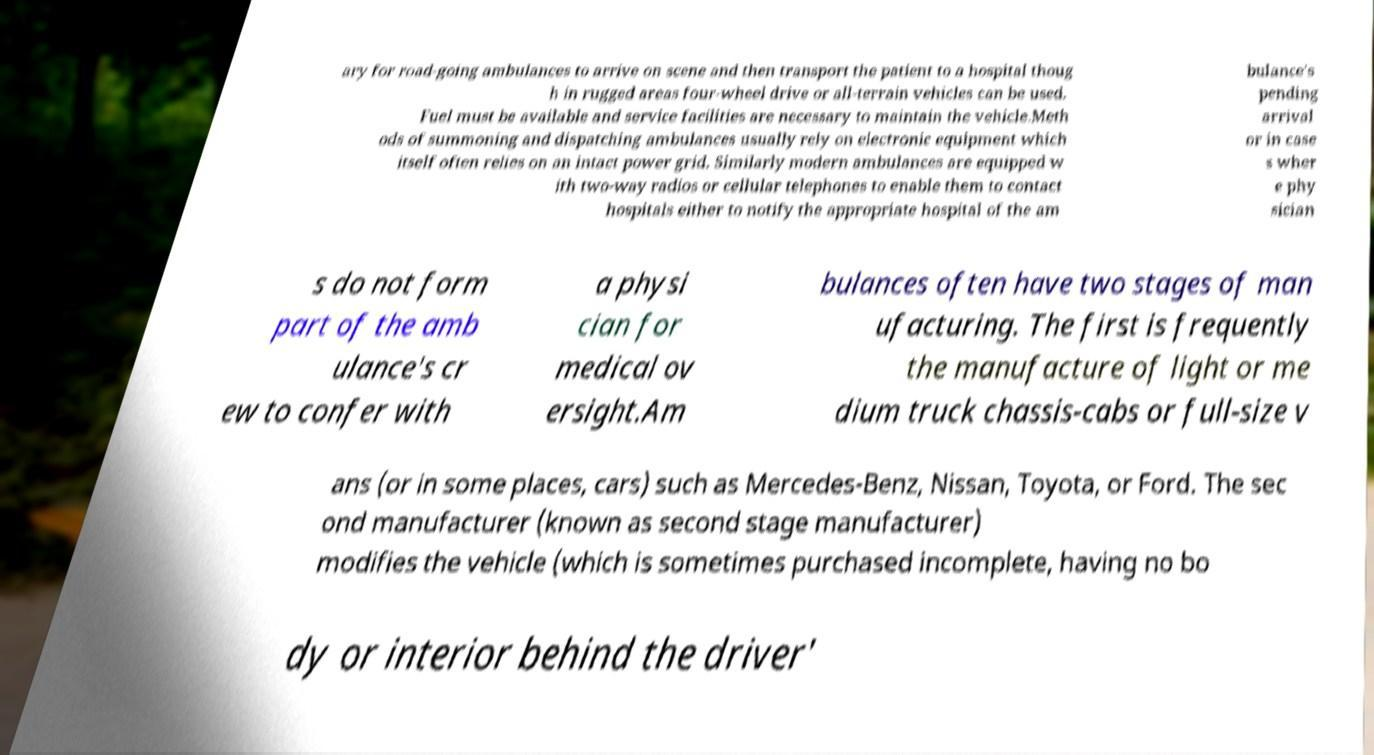I need the written content from this picture converted into text. Can you do that? ary for road-going ambulances to arrive on scene and then transport the patient to a hospital thoug h in rugged areas four-wheel drive or all-terrain vehicles can be used. Fuel must be available and service facilities are necessary to maintain the vehicle.Meth ods of summoning and dispatching ambulances usually rely on electronic equipment which itself often relies on an intact power grid. Similarly modern ambulances are equipped w ith two-way radios or cellular telephones to enable them to contact hospitals either to notify the appropriate hospital of the am bulance's pending arrival or in case s wher e phy sician s do not form part of the amb ulance's cr ew to confer with a physi cian for medical ov ersight.Am bulances often have two stages of man ufacturing. The first is frequently the manufacture of light or me dium truck chassis-cabs or full-size v ans (or in some places, cars) such as Mercedes-Benz, Nissan, Toyota, or Ford. The sec ond manufacturer (known as second stage manufacturer) modifies the vehicle (which is sometimes purchased incomplete, having no bo dy or interior behind the driver' 